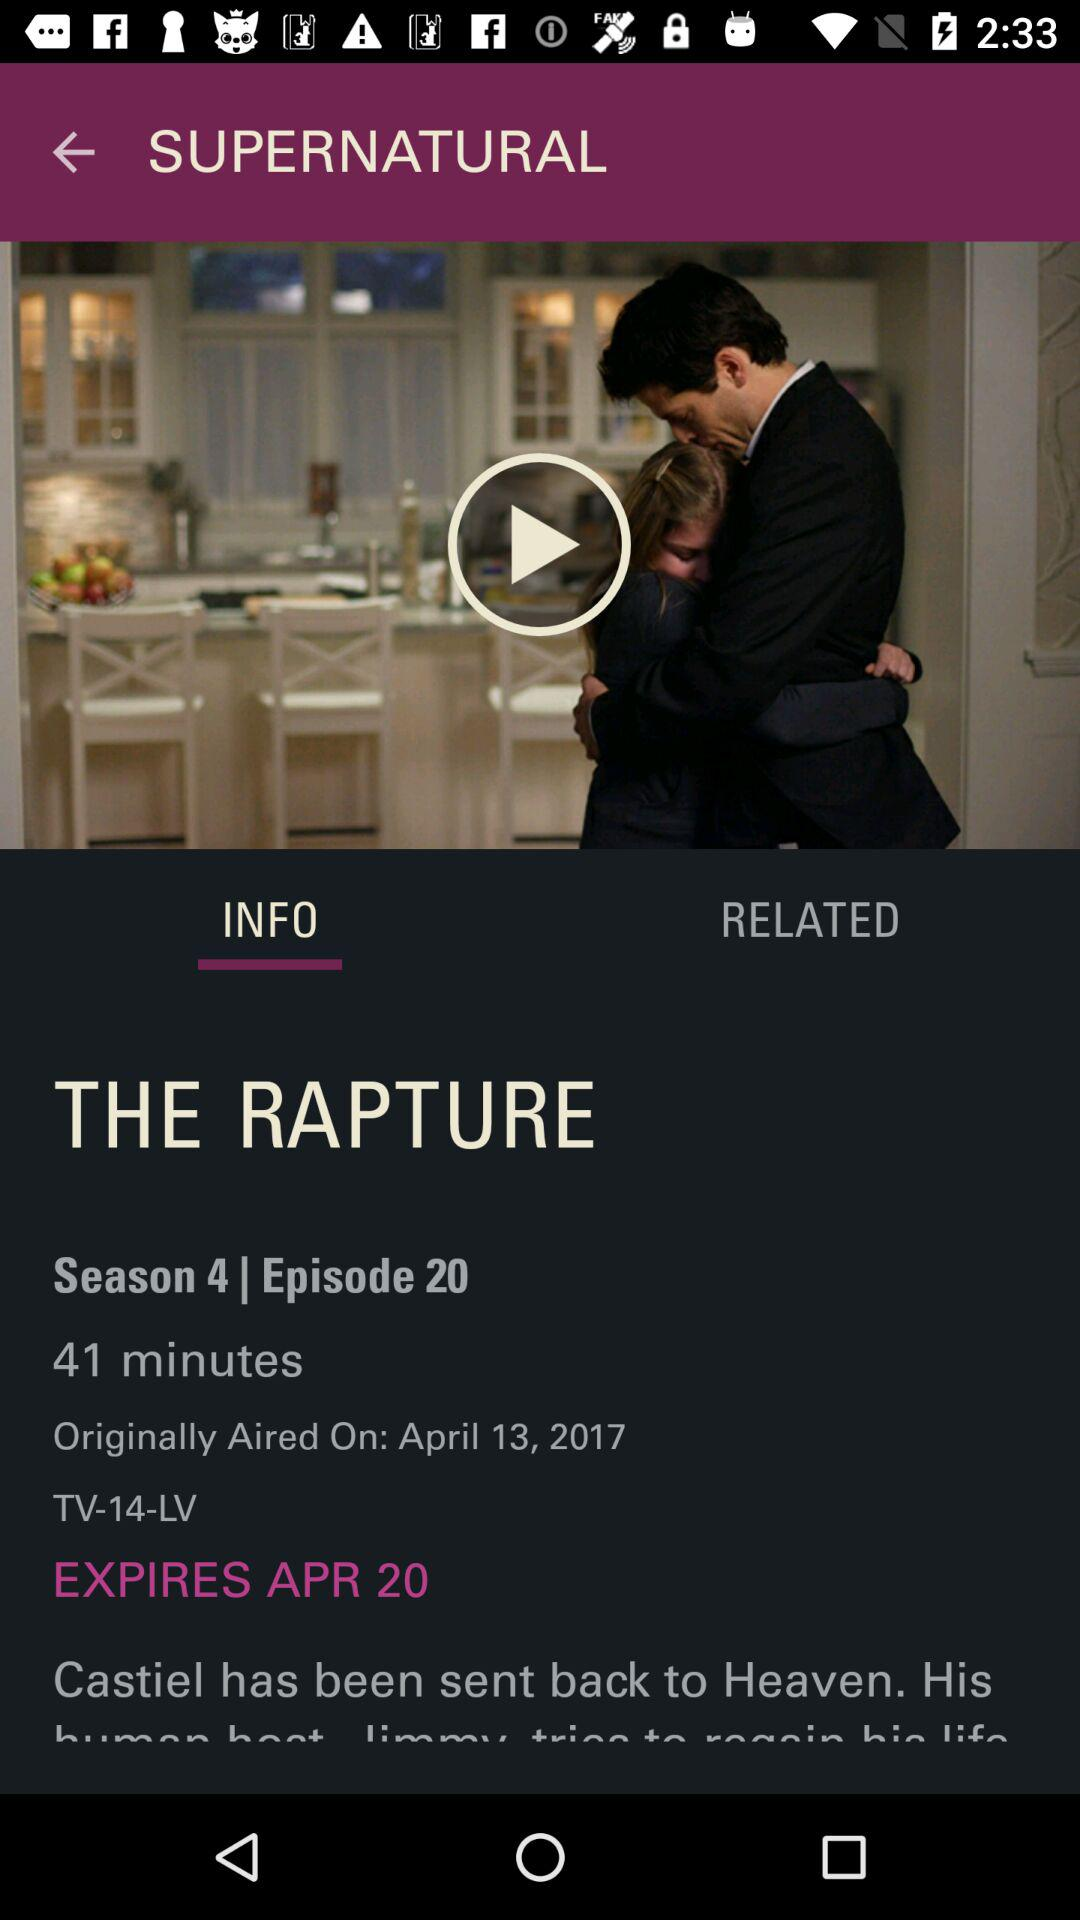What is the title of the episode? The title of the episode is "THE RAPTURE". 